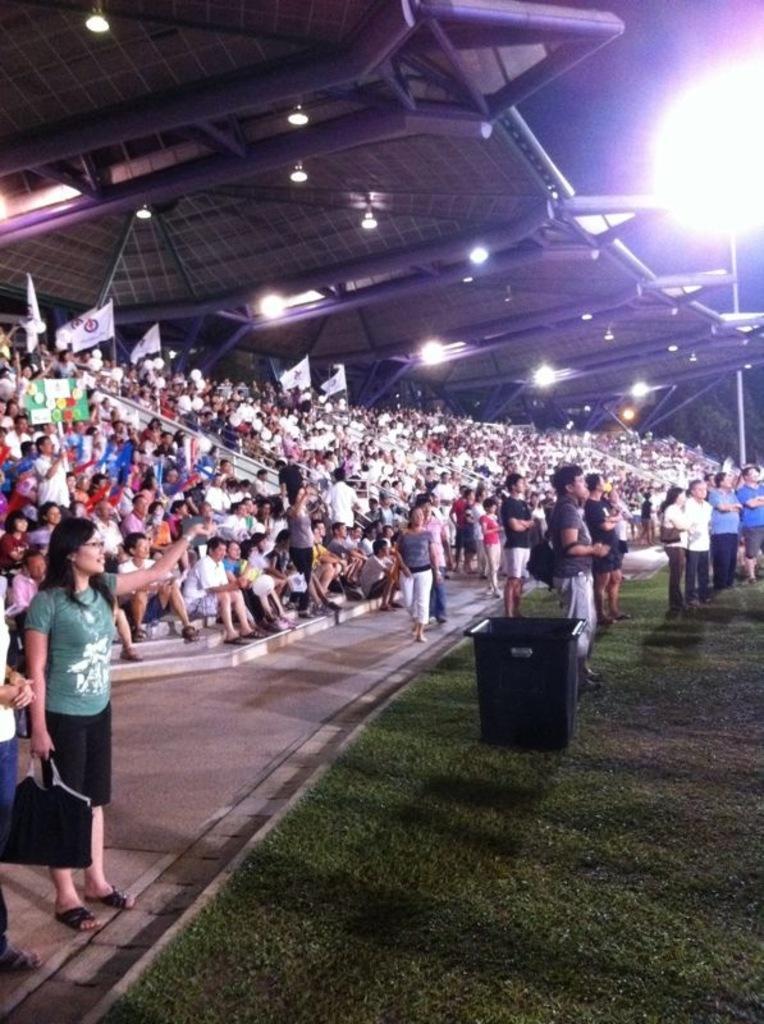Can you describe this image briefly? In this image I can see group of people, some are sitting and some are standing. In front the person is wearing green and black color dress and I can also see few poles and few lights. 